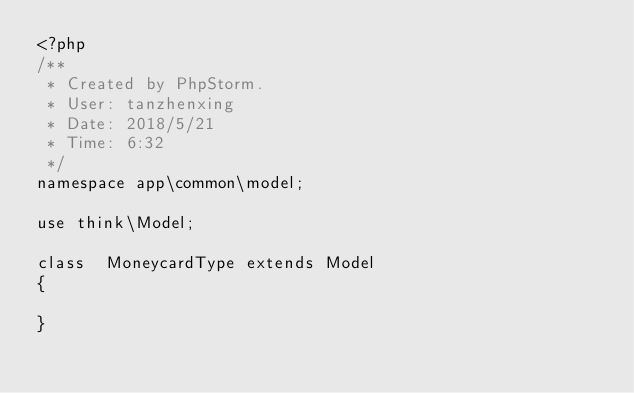Convert code to text. <code><loc_0><loc_0><loc_500><loc_500><_PHP_><?php
/**
 * Created by PhpStorm.
 * User: tanzhenxing
 * Date: 2018/5/21
 * Time: 6:32
 */
namespace app\common\model;

use think\Model;

class  MoneycardType extends Model
{

}</code> 